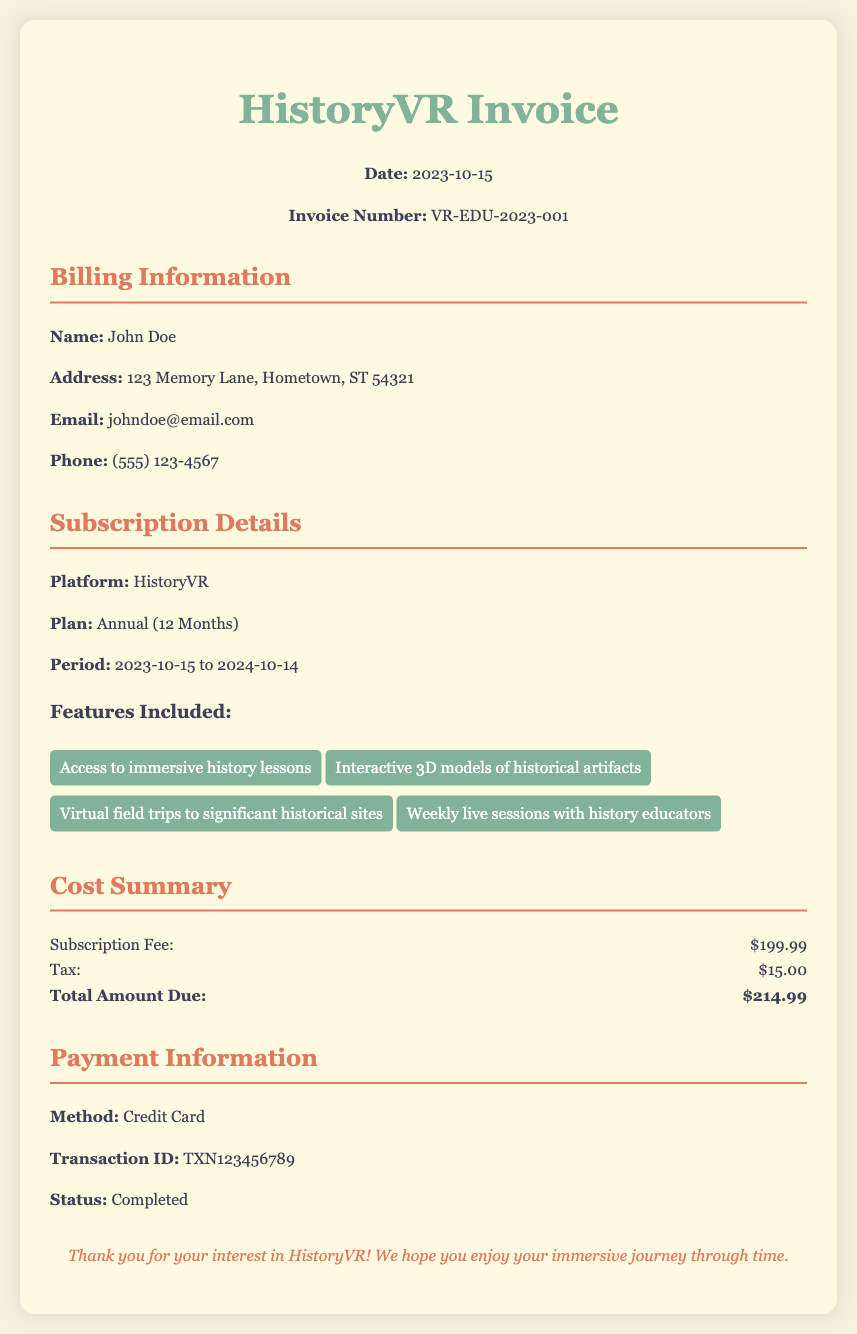What is the invoice number? The invoice number is a unique identifier for the transaction, listed in the document.
Answer: VR-EDU-2023-001 What is the subscription fee? The subscription fee is the cost for the chosen plan and is specified in the cost summary section.
Answer: $199.99 Who is the billing information for? The billing information section identifies the recipient of the invoice by name.
Answer: John Doe What is the total amount due? The total amount due is the sum of the subscription fee and tax, as shown in the cost summary.
Answer: $214.99 When does the subscription period end? The subscription period end date is mentioned in the subscription details section.
Answer: 2024-10-14 How much tax is charged for the subscription? The tax amount is outlined in the cost summary section.
Answer: $15.00 What payment method was used? The payment method employed for the transaction is stated in the payment information section.
Answer: Credit Card What feature allows virtual field trips? One of the features listed in the subscription details section emphasizes virtual experiences.
Answer: Virtual field trips to significant historical sites What email address is linked to the billing information? The email address provided for communication is found in the billing information section.
Answer: johndoe@email.com 